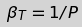Convert formula to latex. <formula><loc_0><loc_0><loc_500><loc_500>\beta _ { T } = 1 / P</formula> 